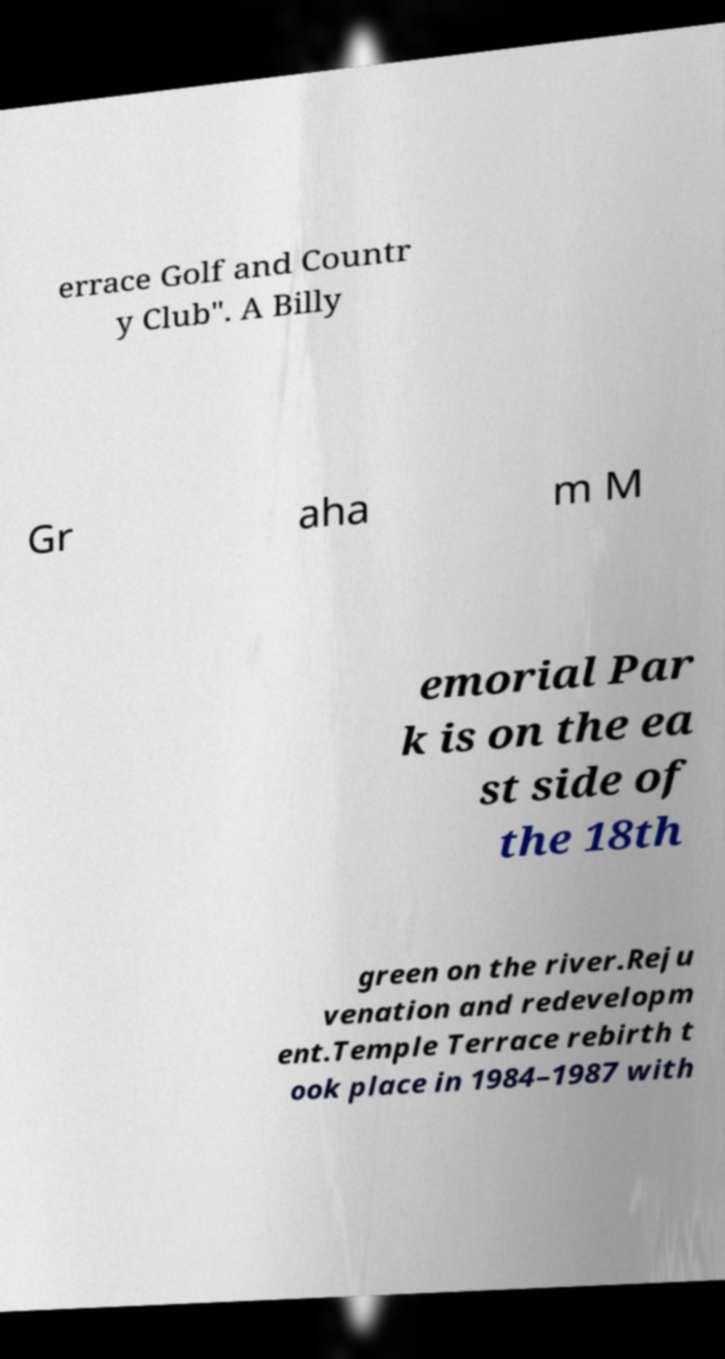What messages or text are displayed in this image? I need them in a readable, typed format. errace Golf and Countr y Club". A Billy Gr aha m M emorial Par k is on the ea st side of the 18th green on the river.Reju venation and redevelopm ent.Temple Terrace rebirth t ook place in 1984–1987 with 